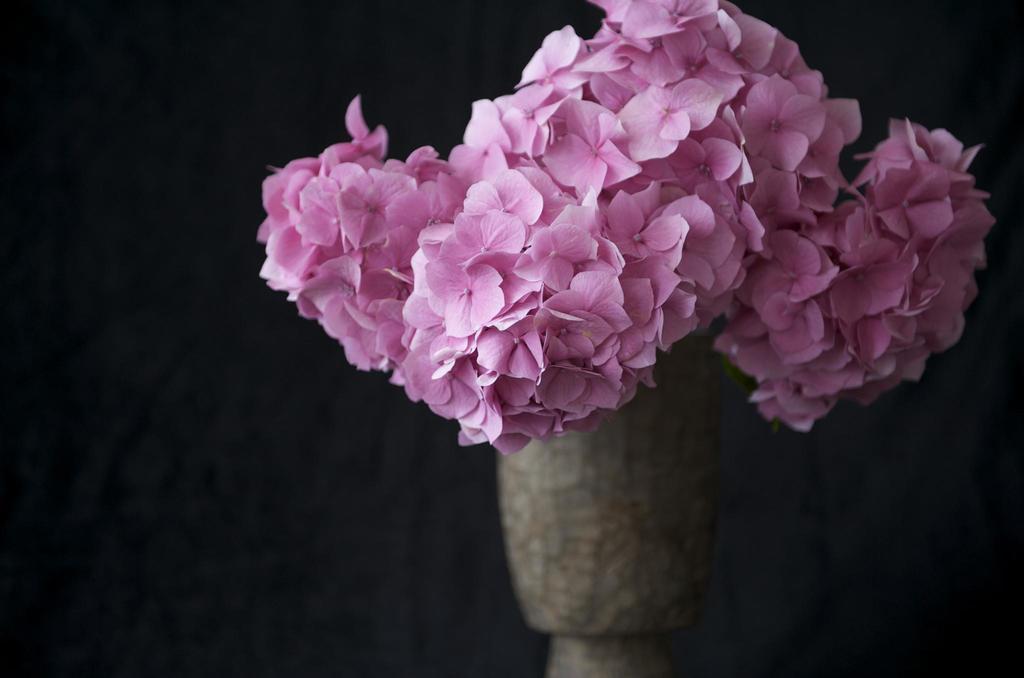Please provide a concise description of this image. In the image there are pink flowers in the foreground the background of the flowers is blur. 